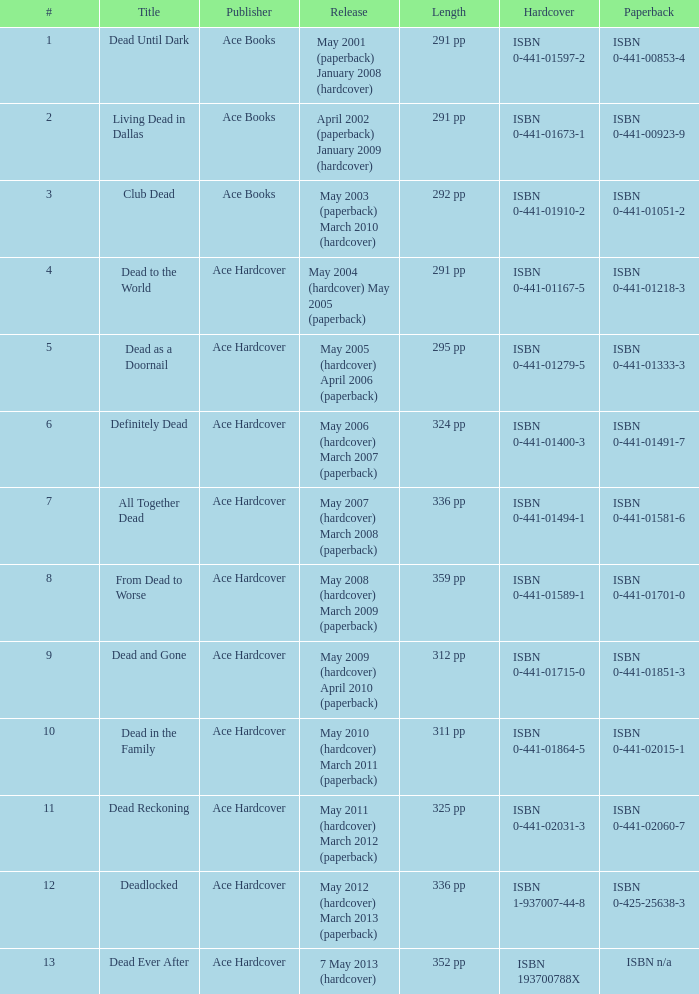Who pubilshed isbn 1-937007-44-8? Ace Hardcover. Could you parse the entire table as a dict? {'header': ['#', 'Title', 'Publisher', 'Release', 'Length', 'Hardcover', 'Paperback'], 'rows': [['1', 'Dead Until Dark', 'Ace Books', 'May 2001 (paperback) January 2008 (hardcover)', '291 pp', 'ISBN 0-441-01597-2', 'ISBN 0-441-00853-4'], ['2', 'Living Dead in Dallas', 'Ace Books', 'April 2002 (paperback) January 2009 (hardcover)', '291 pp', 'ISBN 0-441-01673-1', 'ISBN 0-441-00923-9'], ['3', 'Club Dead', 'Ace Books', 'May 2003 (paperback) March 2010 (hardcover)', '292 pp', 'ISBN 0-441-01910-2', 'ISBN 0-441-01051-2'], ['4', 'Dead to the World', 'Ace Hardcover', 'May 2004 (hardcover) May 2005 (paperback)', '291 pp', 'ISBN 0-441-01167-5', 'ISBN 0-441-01218-3'], ['5', 'Dead as a Doornail', 'Ace Hardcover', 'May 2005 (hardcover) April 2006 (paperback)', '295 pp', 'ISBN 0-441-01279-5', 'ISBN 0-441-01333-3'], ['6', 'Definitely Dead', 'Ace Hardcover', 'May 2006 (hardcover) March 2007 (paperback)', '324 pp', 'ISBN 0-441-01400-3', 'ISBN 0-441-01491-7'], ['7', 'All Together Dead', 'Ace Hardcover', 'May 2007 (hardcover) March 2008 (paperback)', '336 pp', 'ISBN 0-441-01494-1', 'ISBN 0-441-01581-6'], ['8', 'From Dead to Worse', 'Ace Hardcover', 'May 2008 (hardcover) March 2009 (paperback)', '359 pp', 'ISBN 0-441-01589-1', 'ISBN 0-441-01701-0'], ['9', 'Dead and Gone', 'Ace Hardcover', 'May 2009 (hardcover) April 2010 (paperback)', '312 pp', 'ISBN 0-441-01715-0', 'ISBN 0-441-01851-3'], ['10', 'Dead in the Family', 'Ace Hardcover', 'May 2010 (hardcover) March 2011 (paperback)', '311 pp', 'ISBN 0-441-01864-5', 'ISBN 0-441-02015-1'], ['11', 'Dead Reckoning', 'Ace Hardcover', 'May 2011 (hardcover) March 2012 (paperback)', '325 pp', 'ISBN 0-441-02031-3', 'ISBN 0-441-02060-7'], ['12', 'Deadlocked', 'Ace Hardcover', 'May 2012 (hardcover) March 2013 (paperback)', '336 pp', 'ISBN 1-937007-44-8', 'ISBN 0-425-25638-3'], ['13', 'Dead Ever After', 'Ace Hardcover', '7 May 2013 (hardcover)', '352 pp', 'ISBN 193700788X', 'ISBN n/a']]} 